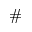<formula> <loc_0><loc_0><loc_500><loc_500>\#</formula> 